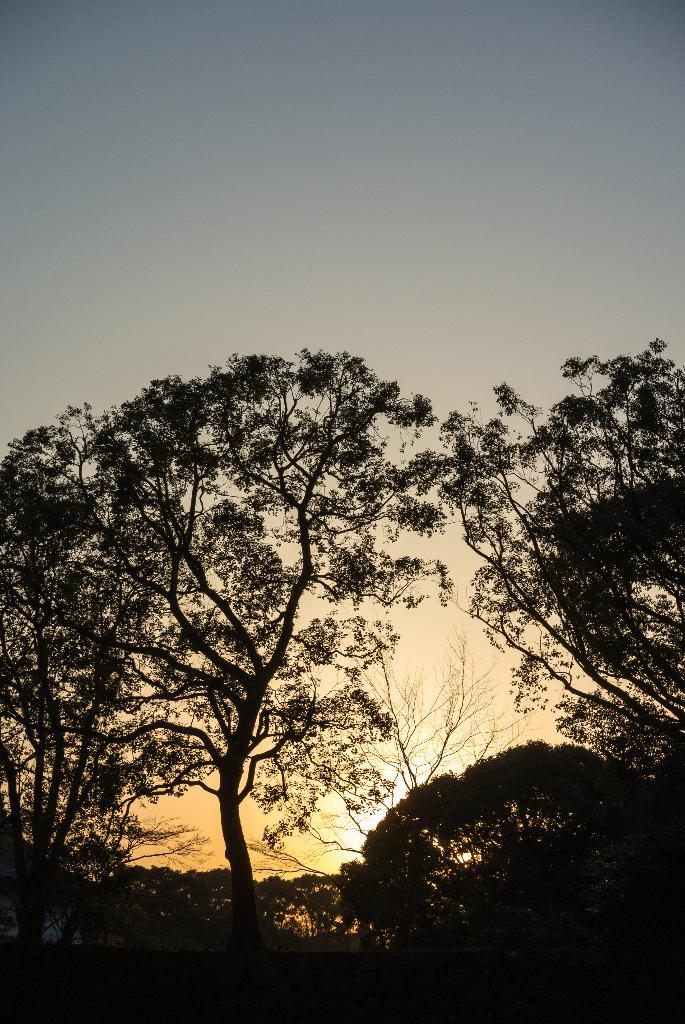What type of vegetation can be seen in the image? There are trees in the image. What part of the natural environment is visible in the image? The sky is visible in the background of the image. What type of wrist accessory is visible on the trees in the image? There are no wrist accessories present in the image; it features trees and the sky. How does the swing interact with the trees in the image? There is no swing present in the image; it only features trees and the sky. 